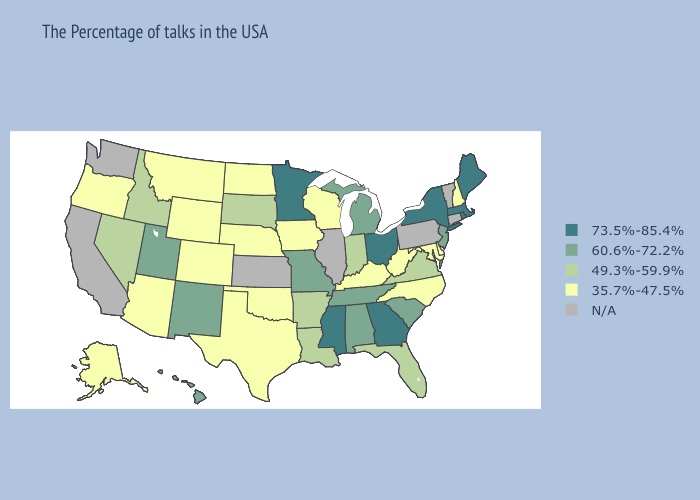What is the value of New Hampshire?
Be succinct. 35.7%-47.5%. Does Alabama have the lowest value in the South?
Answer briefly. No. Among the states that border Delaware , which have the highest value?
Quick response, please. New Jersey. Name the states that have a value in the range N/A?
Answer briefly. Vermont, Connecticut, Pennsylvania, Illinois, Kansas, California, Washington. Name the states that have a value in the range 60.6%-72.2%?
Concise answer only. New Jersey, South Carolina, Michigan, Alabama, Tennessee, Missouri, New Mexico, Utah, Hawaii. What is the lowest value in the MidWest?
Quick response, please. 35.7%-47.5%. What is the value of South Dakota?
Concise answer only. 49.3%-59.9%. What is the highest value in the USA?
Write a very short answer. 73.5%-85.4%. Does the map have missing data?
Concise answer only. Yes. What is the highest value in the USA?
Quick response, please. 73.5%-85.4%. What is the value of Arizona?
Quick response, please. 35.7%-47.5%. Does the first symbol in the legend represent the smallest category?
Be succinct. No. Which states have the highest value in the USA?
Write a very short answer. Maine, Massachusetts, Rhode Island, New York, Ohio, Georgia, Mississippi, Minnesota. 